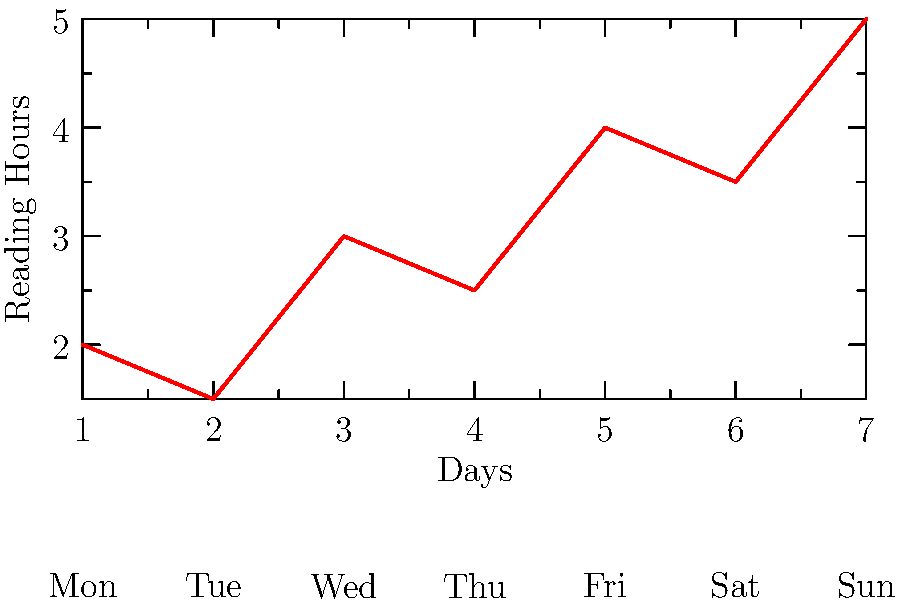Based on the line graph showing daily reading times for a week, what reading pattern can be observed, and how might this information be useful for planning future reading sprints? To analyze the reading pattern and its implications for future reading sprints, let's break down the graph:

1. Daily progression:
   - Monday: 2 hours
   - Tuesday: 1.5 hours (slight decrease)
   - Wednesday: 3 hours (significant increase)
   - Thursday: 2.5 hours (slight decrease)
   - Friday: 4 hours (significant increase)
   - Saturday: 3.5 hours (slight decrease)
   - Sunday: 5 hours (increase to week's peak)

2. Overall trend: There's a general upward trend in reading time throughout the week.

3. Pattern observation: Reading time tends to increase on alternate days, with slight decreases in between.

4. Weekend effect: The highest reading times are observed on Friday, Saturday, and Sunday, suggesting more time is available for reading on weekends.

5. Implications for reading sprints:
   a. Weekday sprints could be shorter (1.5-3 hours) to accommodate busy schedules.
   b. Weekend sprints could be longer (3.5-5 hours) to take advantage of increased available time.
   c. Alternating between longer and shorter sprints throughout the week might align well with the observed reading pattern.
   d. Sunday could be ideal for a marathon reading sprint, given the peak reading time.

This pattern suggests a "crescendo" approach to reading throughout the week, which could be leveraged to design engaging and realistic reading sprint schedules for the booktuber's audience.
Answer: Increasing reading time throughout the week, peaking on weekends; plan shorter weekday sprints and longer weekend sprints. 